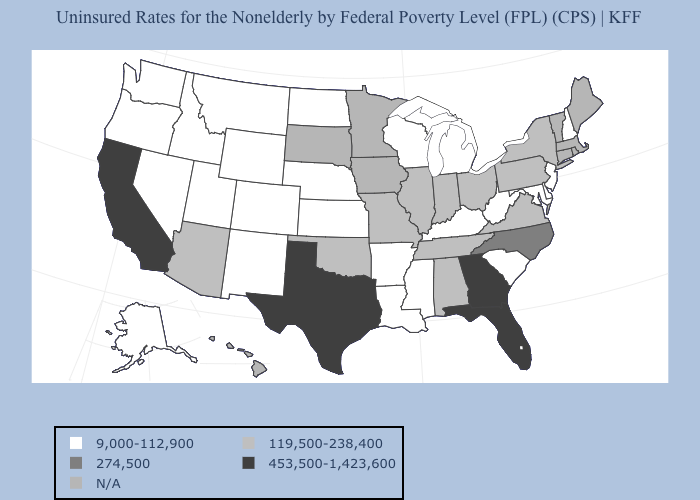Name the states that have a value in the range 9,000-112,900?
Concise answer only. Alaska, Arkansas, Colorado, Delaware, Idaho, Kansas, Kentucky, Louisiana, Maryland, Michigan, Mississippi, Montana, Nebraska, Nevada, New Hampshire, New Jersey, New Mexico, North Dakota, Oregon, South Carolina, Utah, Washington, West Virginia, Wisconsin, Wyoming. Does Idaho have the lowest value in the West?
Short answer required. Yes. Does California have the lowest value in the West?
Short answer required. No. Name the states that have a value in the range 119,500-238,400?
Be succinct. Alabama, Arizona, Illinois, Indiana, Missouri, New York, Ohio, Oklahoma, Pennsylvania, Tennessee, Virginia. What is the value of Michigan?
Give a very brief answer. 9,000-112,900. Does the map have missing data?
Answer briefly. Yes. Name the states that have a value in the range 9,000-112,900?
Give a very brief answer. Alaska, Arkansas, Colorado, Delaware, Idaho, Kansas, Kentucky, Louisiana, Maryland, Michigan, Mississippi, Montana, Nebraska, Nevada, New Hampshire, New Jersey, New Mexico, North Dakota, Oregon, South Carolina, Utah, Washington, West Virginia, Wisconsin, Wyoming. Does Oklahoma have the lowest value in the South?
Give a very brief answer. No. Does the first symbol in the legend represent the smallest category?
Short answer required. Yes. Name the states that have a value in the range 9,000-112,900?
Give a very brief answer. Alaska, Arkansas, Colorado, Delaware, Idaho, Kansas, Kentucky, Louisiana, Maryland, Michigan, Mississippi, Montana, Nebraska, Nevada, New Hampshire, New Jersey, New Mexico, North Dakota, Oregon, South Carolina, Utah, Washington, West Virginia, Wisconsin, Wyoming. What is the highest value in the Northeast ?
Be succinct. 119,500-238,400. What is the value of Virginia?
Keep it brief. 119,500-238,400. What is the lowest value in the Northeast?
Quick response, please. 9,000-112,900. Name the states that have a value in the range 9,000-112,900?
Answer briefly. Alaska, Arkansas, Colorado, Delaware, Idaho, Kansas, Kentucky, Louisiana, Maryland, Michigan, Mississippi, Montana, Nebraska, Nevada, New Hampshire, New Jersey, New Mexico, North Dakota, Oregon, South Carolina, Utah, Washington, West Virginia, Wisconsin, Wyoming. 